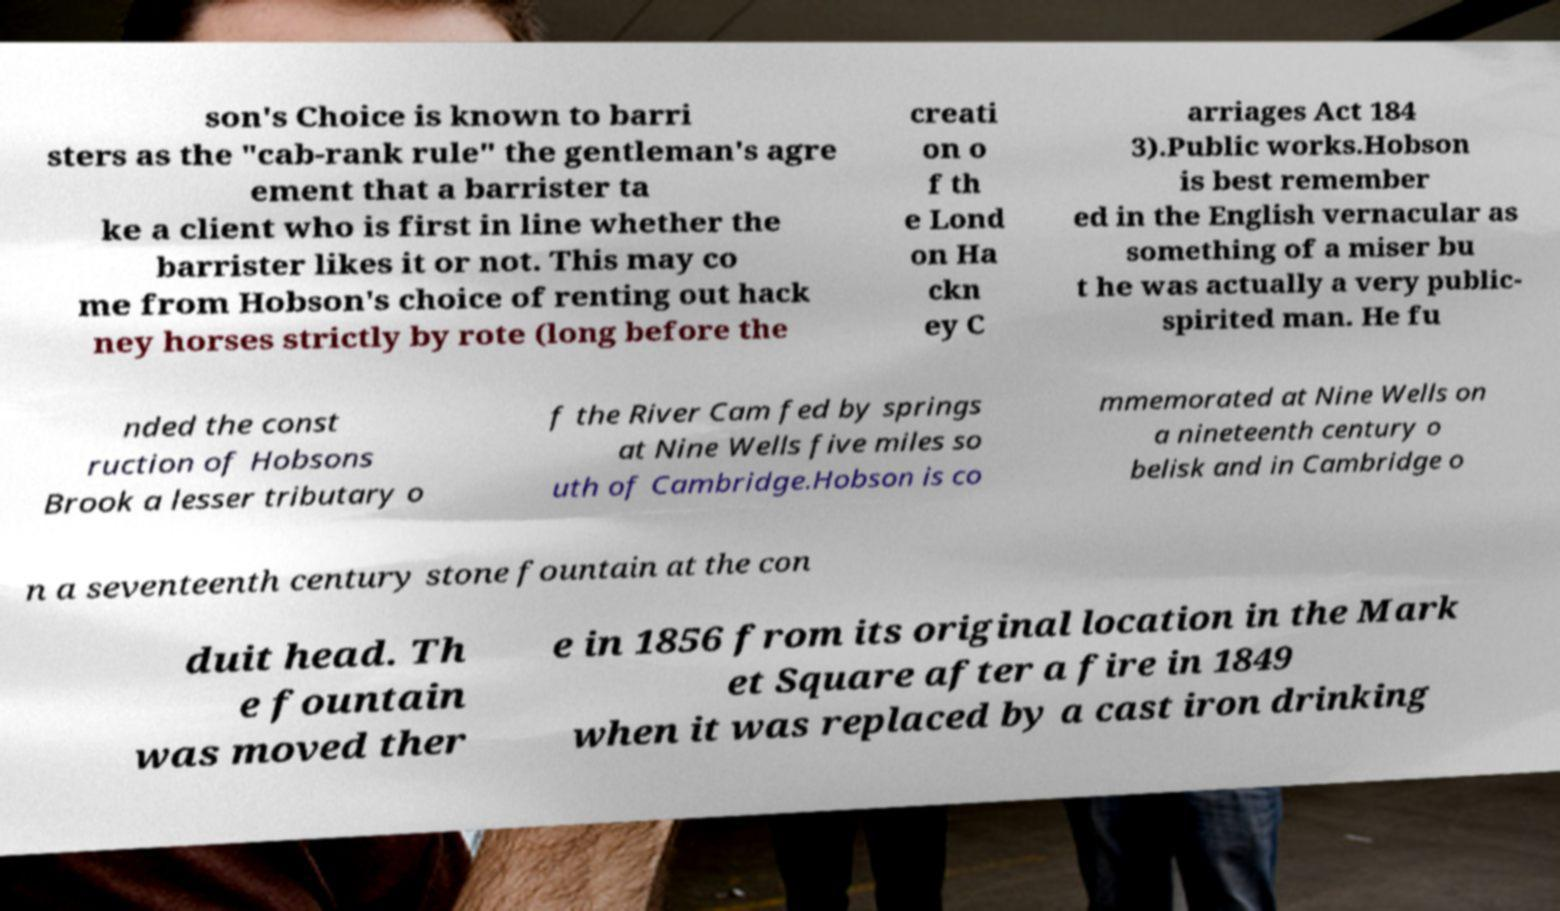Please identify and transcribe the text found in this image. son's Choice is known to barri sters as the "cab-rank rule" the gentleman's agre ement that a barrister ta ke a client who is first in line whether the barrister likes it or not. This may co me from Hobson's choice of renting out hack ney horses strictly by rote (long before the creati on o f th e Lond on Ha ckn ey C arriages Act 184 3).Public works.Hobson is best remember ed in the English vernacular as something of a miser bu t he was actually a very public- spirited man. He fu nded the const ruction of Hobsons Brook a lesser tributary o f the River Cam fed by springs at Nine Wells five miles so uth of Cambridge.Hobson is co mmemorated at Nine Wells on a nineteenth century o belisk and in Cambridge o n a seventeenth century stone fountain at the con duit head. Th e fountain was moved ther e in 1856 from its original location in the Mark et Square after a fire in 1849 when it was replaced by a cast iron drinking 